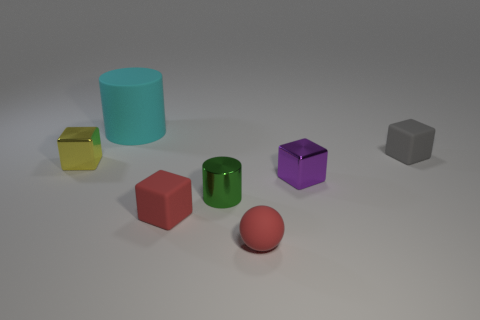What is the material of the cube that is the same color as the matte ball?
Your response must be concise. Rubber. There is a metal block that is on the left side of the small metallic cylinder that is in front of the yellow object; what number of small shiny things are to the left of it?
Keep it short and to the point. 0. How many large objects are either red rubber cubes or cylinders?
Keep it short and to the point. 1. Is the material of the tiny block in front of the tiny green object the same as the tiny yellow thing?
Your answer should be very brief. No. There is a cylinder in front of the block that is left of the cylinder behind the small gray rubber block; what is its material?
Offer a terse response. Metal. Is there any other thing that is the same size as the green cylinder?
Provide a short and direct response. Yes. What number of metallic objects are blocks or gray cubes?
Your response must be concise. 2. Is there a tiny red matte ball?
Give a very brief answer. Yes. What is the color of the small rubber object that is behind the tiny red object behind the tiny red sphere?
Your answer should be compact. Gray. What number of other things are the same color as the rubber cylinder?
Offer a terse response. 0. 